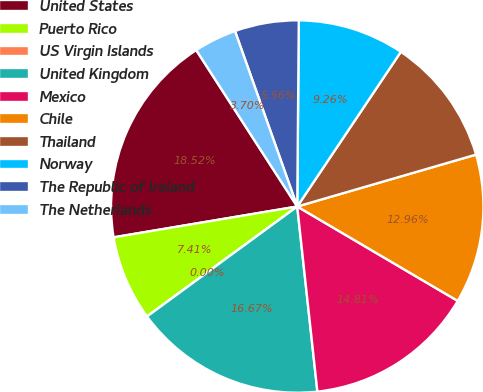<chart> <loc_0><loc_0><loc_500><loc_500><pie_chart><fcel>United States<fcel>Puerto Rico<fcel>US Virgin Islands<fcel>United Kingdom<fcel>Mexico<fcel>Chile<fcel>Thailand<fcel>Norway<fcel>The Republic of Ireland<fcel>The Netherlands<nl><fcel>18.52%<fcel>7.41%<fcel>0.0%<fcel>16.67%<fcel>14.81%<fcel>12.96%<fcel>11.11%<fcel>9.26%<fcel>5.56%<fcel>3.7%<nl></chart> 